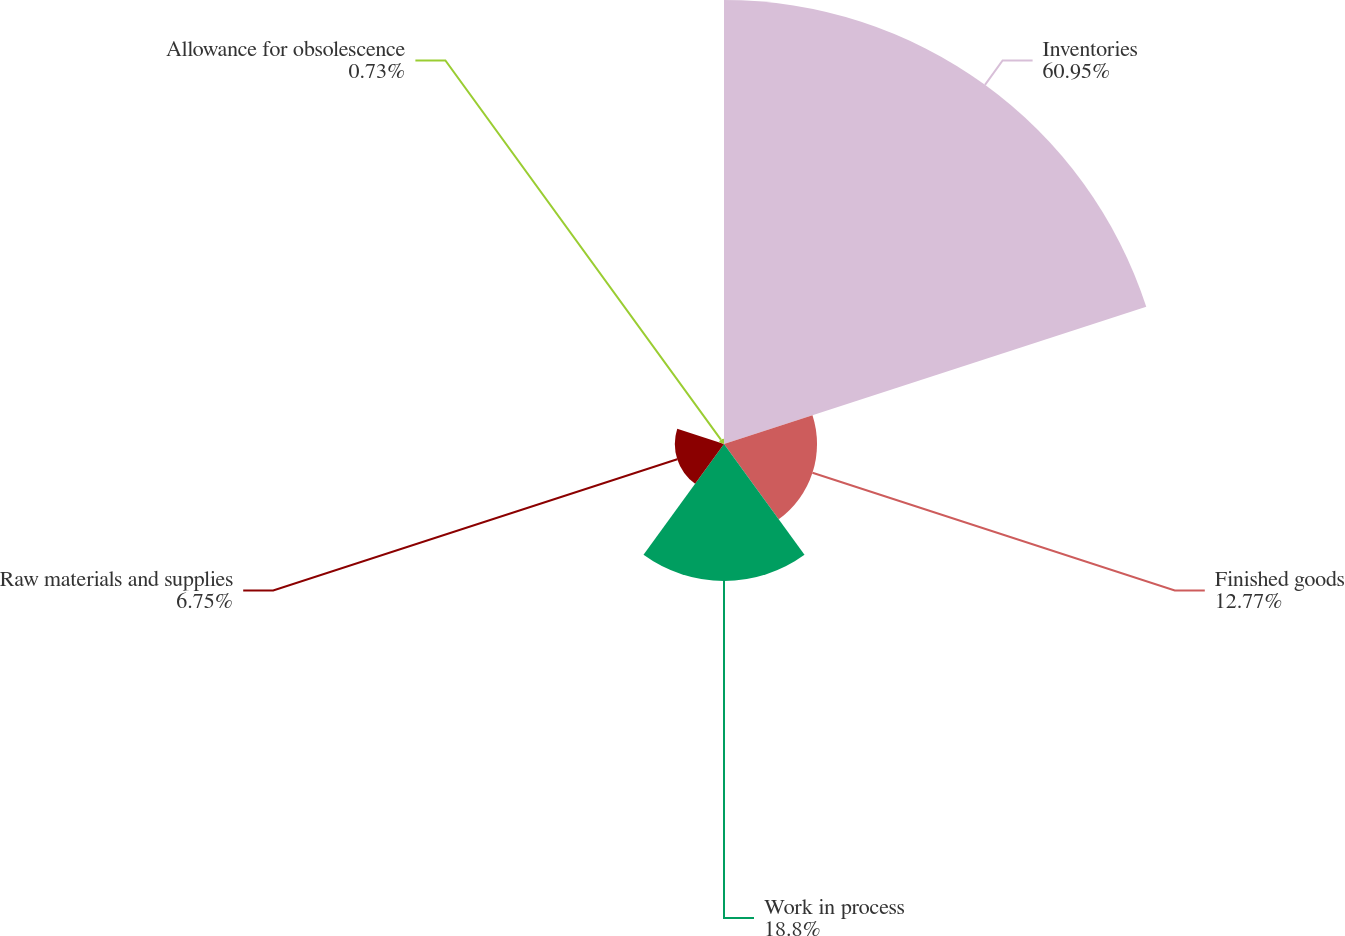Convert chart to OTSL. <chart><loc_0><loc_0><loc_500><loc_500><pie_chart><fcel>Inventories<fcel>Finished goods<fcel>Work in process<fcel>Raw materials and supplies<fcel>Allowance for obsolescence<nl><fcel>60.95%<fcel>12.77%<fcel>18.8%<fcel>6.75%<fcel>0.73%<nl></chart> 